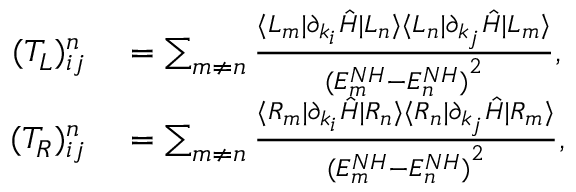Convert formula to latex. <formula><loc_0><loc_0><loc_500><loc_500>\begin{array} { r l } { ( T _ { L } ) _ { i j } ^ { n } } & = \sum _ { m \neq n } \frac { \langle L _ { m } | \partial _ { k _ { i } } \hat { H } | L _ { n } \rangle \langle L _ { n } | \partial _ { k _ { j } } \hat { H } | L _ { m } \rangle } { { ( E _ { m } ^ { N H } - E _ { n } ^ { N H } ) } ^ { 2 } } , } \\ { ( T _ { R } ) _ { i j } ^ { n } } & = \sum _ { m \neq n } \frac { \langle R _ { m } | \partial _ { k _ { i } } \hat { H } | R _ { n } \rangle \langle R _ { n } | \partial _ { k _ { j } } \hat { H } | R _ { m } \rangle } { { ( E _ { m } ^ { N H } - E _ { n } ^ { N H } ) } ^ { 2 } } , } \end{array}</formula> 